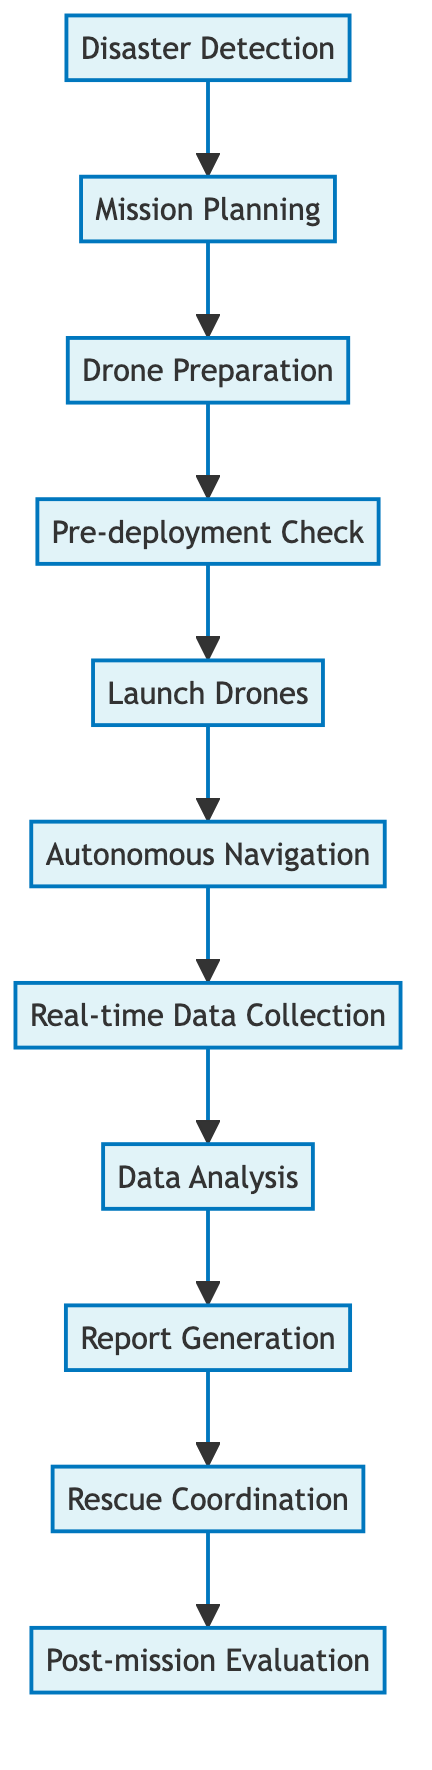What is the first step in the workflow? The first step in the workflow is indicated by the first node in the diagram, which is "Disaster Detection." This is the starting point before any other processes are carried out.
Answer: Disaster Detection How many processes are shown in the diagram? To determine the number of processes, we can count the nodes labeled as processes in the diagram. There are eleven nodes defined, each representing a distinct process in the workflow.
Answer: Eleven What follows after "Launch Drones"? Looking at the flow direction indicated by the arrows, "Launch Drones" is followed by the process labeled "Autonomous Navigation," which is the next step after launching the drones.
Answer: Autonomous Navigation Which process generates reports? The process that generates reports is seen as one of the later steps in the flow, specifically the node labeled "Report Generation." This is where detailed reports are created based on previously analyzed data.
Answer: Report Generation What process happens before "Data Analysis"? To find the process that occurs prior to "Data Analysis," we trace back the workflow from "Data Analysis," which leads us to "Real-time Data Collection." This is the immediate step that occurs before data analysis takes place.
Answer: Real-time Data Collection What is the last step in the workflow? The last step in the workflow is indicated by the final node in the diagram, which is "Post-mission Evaluation." This is where the mission's performance is evaluated after all previous steps have been completed.
Answer: Post-mission Evaluation What connects "Pre-deployment Check" with "Launch Drones"? The connection between "Pre-deployment Check" and "Launch Drones" is indicated by the directed arrow in the flow chart, denoting that "Pre-deployment Check" must be completed before proceeding to "Launch Drones."
Answer: Arrow What is the purpose of "Real-time Data Collection"? The purpose of "Real-time Data Collection" is defined in the node label itself as it involves collecting real-time data using onboard cameras and sensors to assess the disaster situation effectively.
Answer: Assess the situation What is the relationship between "Report Generation" and "Rescue Coordination"? "Report Generation" leads directly to "Rescue Coordination" in the workflow, which indicates that the reports generated from the analysis assist in coordinating the ground rescue operations.
Answer: Direct relationship 